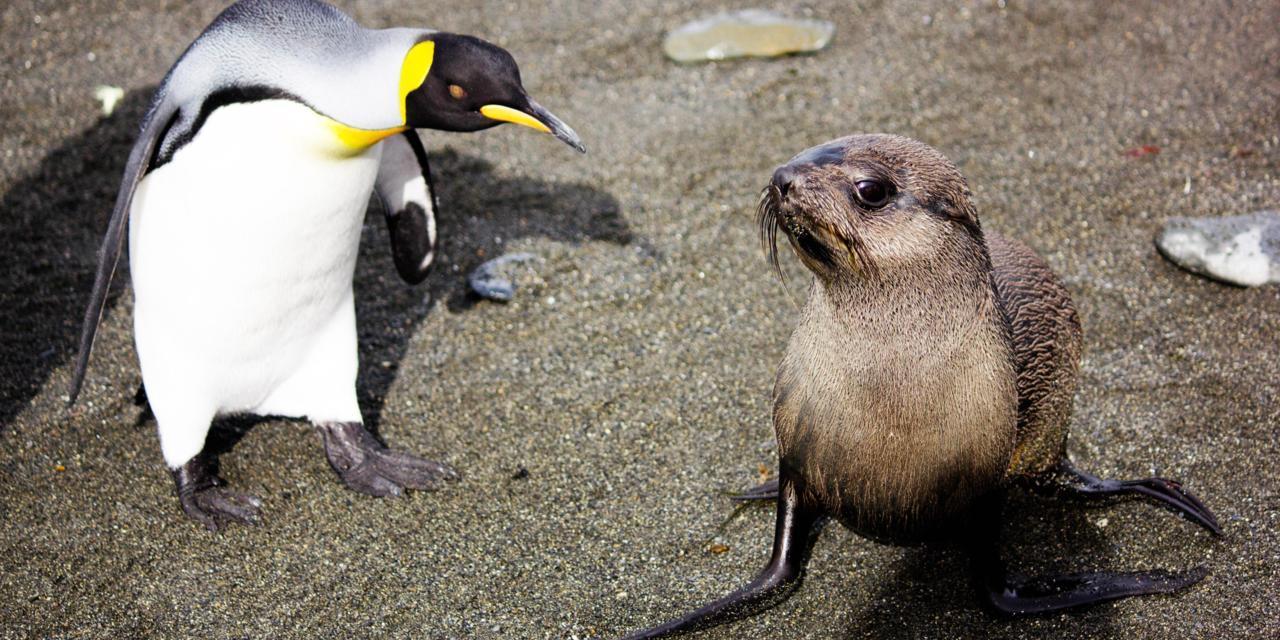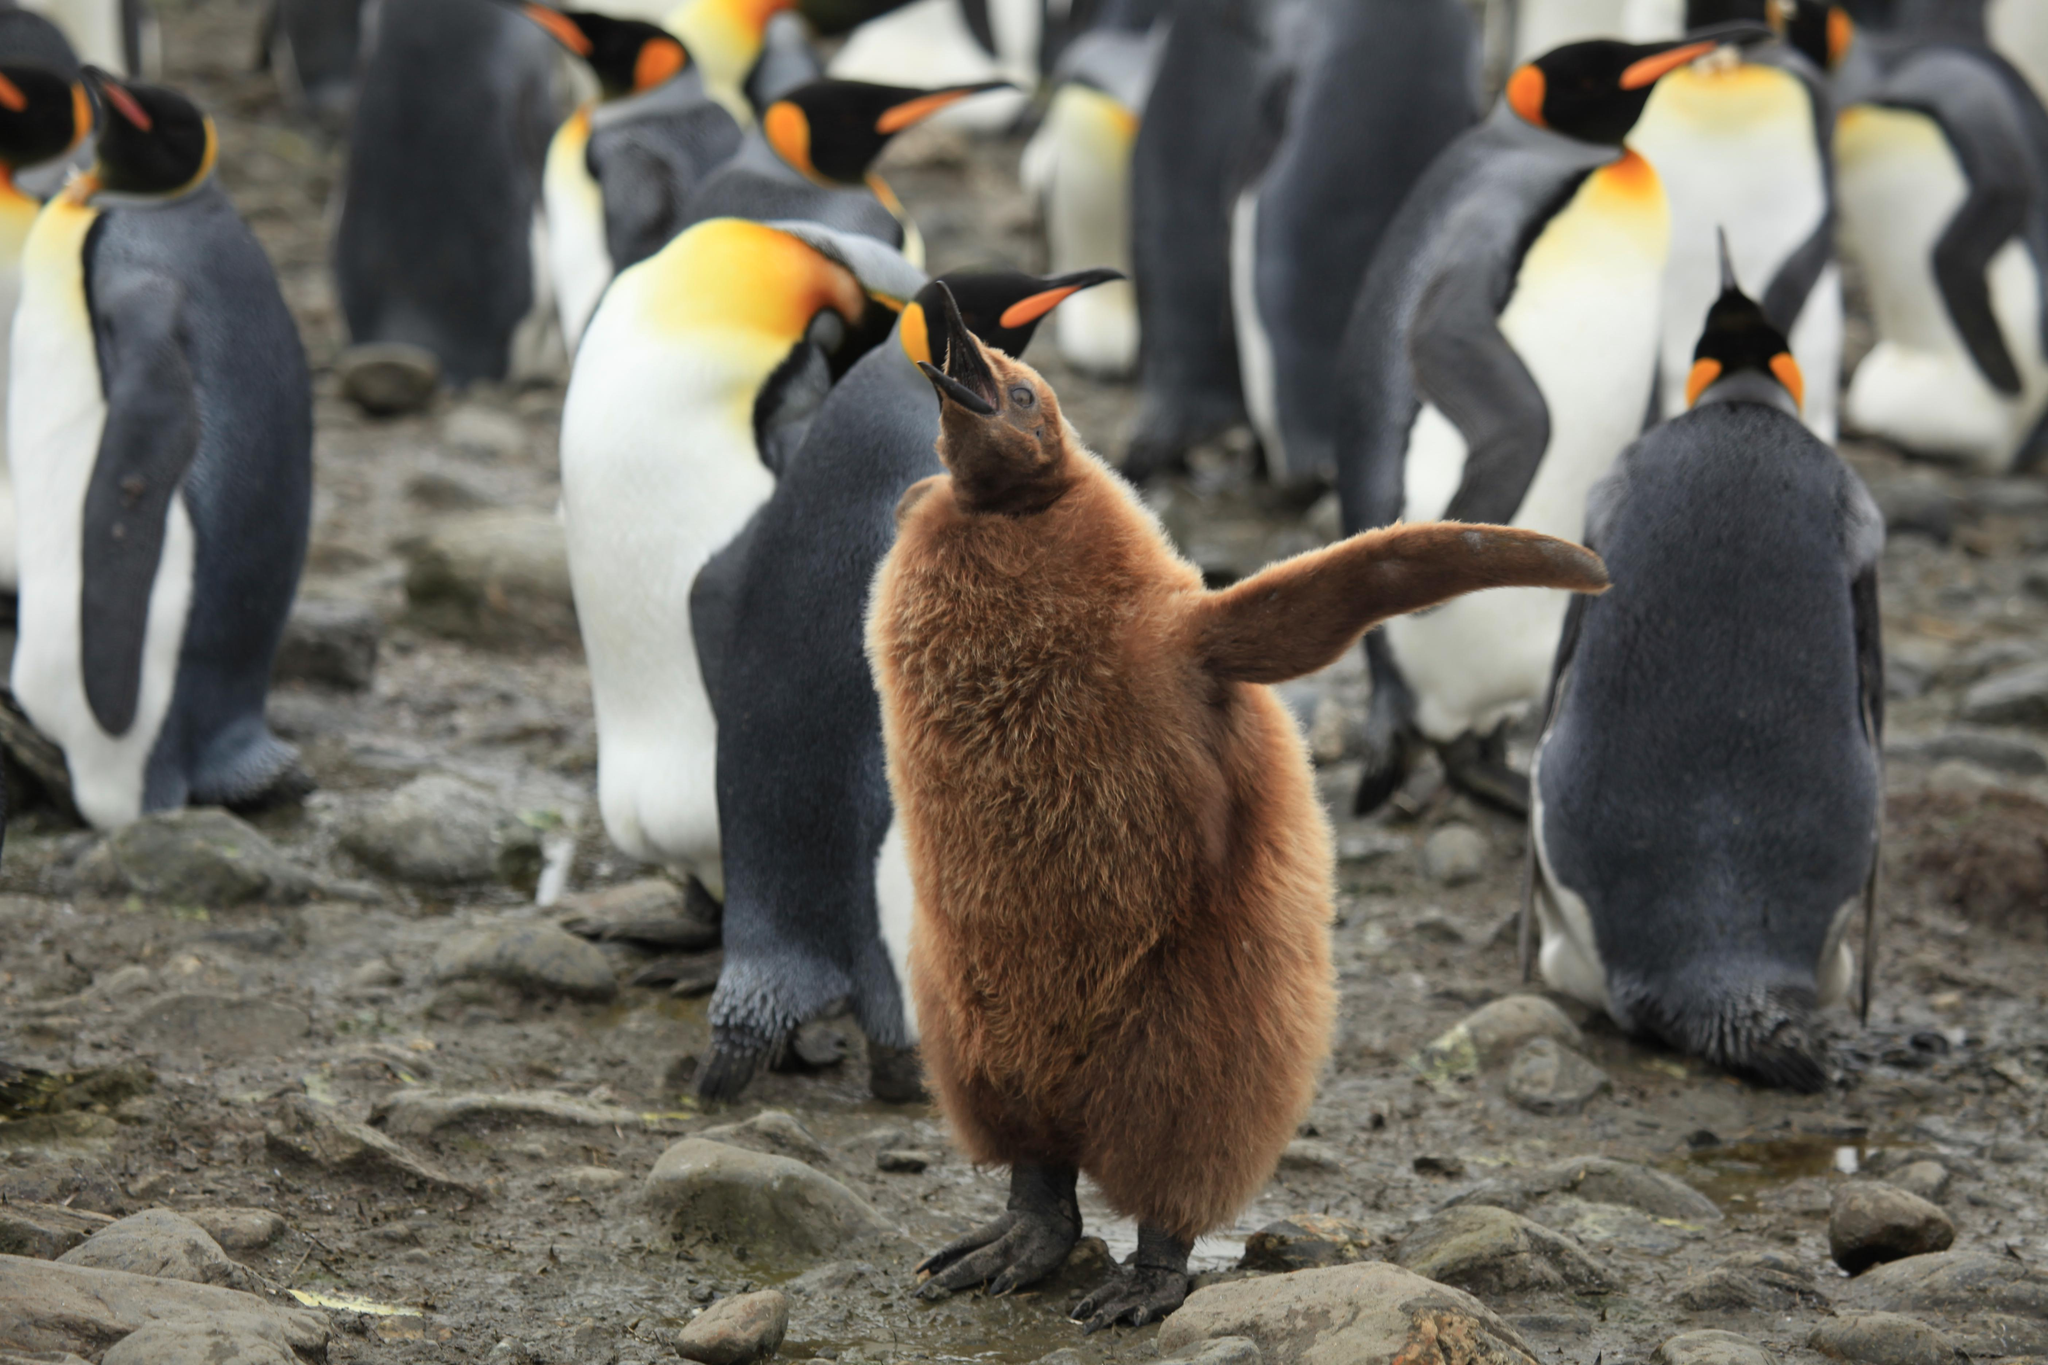The first image is the image on the left, the second image is the image on the right. For the images displayed, is the sentence "There is a single black platypusfacing left  on top of a white, black, and yellow penguin" factually correct? Answer yes or no. No. 